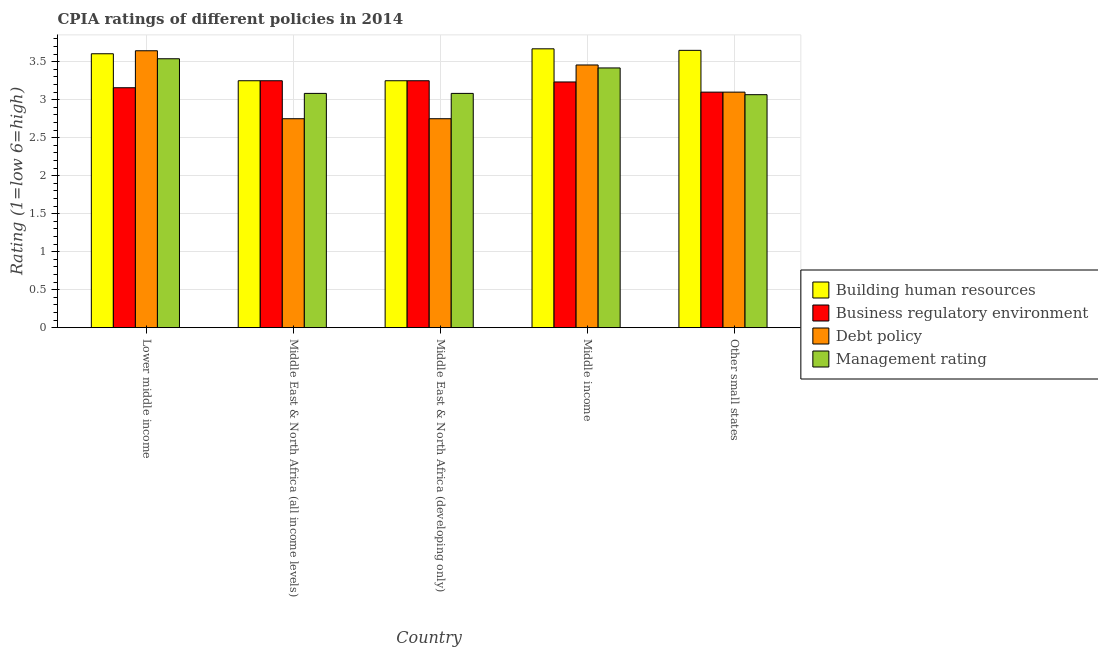How many different coloured bars are there?
Make the answer very short. 4. How many groups of bars are there?
Keep it short and to the point. 5. Are the number of bars per tick equal to the number of legend labels?
Your answer should be compact. Yes. Are the number of bars on each tick of the X-axis equal?
Your answer should be compact. Yes. How many bars are there on the 5th tick from the right?
Offer a very short reply. 4. What is the label of the 3rd group of bars from the left?
Ensure brevity in your answer.  Middle East & North Africa (developing only). In how many cases, is the number of bars for a given country not equal to the number of legend labels?
Give a very brief answer. 0. What is the cpia rating of building human resources in Lower middle income?
Your response must be concise. 3.61. Across all countries, what is the maximum cpia rating of building human resources?
Keep it short and to the point. 3.67. Across all countries, what is the minimum cpia rating of building human resources?
Your answer should be very brief. 3.25. In which country was the cpia rating of debt policy maximum?
Provide a succinct answer. Lower middle income. In which country was the cpia rating of management minimum?
Make the answer very short. Other small states. What is the total cpia rating of building human resources in the graph?
Make the answer very short. 17.43. What is the difference between the cpia rating of building human resources in Middle income and that in Other small states?
Your answer should be compact. 0.02. What is the difference between the cpia rating of building human resources in Middle East & North Africa (developing only) and the cpia rating of management in Middle East & North Africa (all income levels)?
Provide a succinct answer. 0.17. What is the average cpia rating of management per country?
Offer a terse response. 3.24. What is the difference between the cpia rating of debt policy and cpia rating of business regulatory environment in Middle income?
Your answer should be compact. 0.22. What is the ratio of the cpia rating of building human resources in Lower middle income to that in Other small states?
Provide a short and direct response. 0.99. Is the difference between the cpia rating of building human resources in Middle East & North Africa (all income levels) and Middle income greater than the difference between the cpia rating of debt policy in Middle East & North Africa (all income levels) and Middle income?
Keep it short and to the point. Yes. What is the difference between the highest and the second highest cpia rating of business regulatory environment?
Ensure brevity in your answer.  0. What is the difference between the highest and the lowest cpia rating of building human resources?
Keep it short and to the point. 0.42. In how many countries, is the cpia rating of building human resources greater than the average cpia rating of building human resources taken over all countries?
Offer a terse response. 3. What does the 1st bar from the left in Middle East & North Africa (developing only) represents?
Provide a succinct answer. Building human resources. What does the 2nd bar from the right in Other small states represents?
Your response must be concise. Debt policy. Is it the case that in every country, the sum of the cpia rating of building human resources and cpia rating of business regulatory environment is greater than the cpia rating of debt policy?
Make the answer very short. Yes. How many bars are there?
Offer a very short reply. 20. Are all the bars in the graph horizontal?
Make the answer very short. No. How many countries are there in the graph?
Your answer should be compact. 5. What is the difference between two consecutive major ticks on the Y-axis?
Your response must be concise. 0.5. Are the values on the major ticks of Y-axis written in scientific E-notation?
Your response must be concise. No. Does the graph contain any zero values?
Provide a succinct answer. No. Does the graph contain grids?
Give a very brief answer. Yes. How are the legend labels stacked?
Keep it short and to the point. Vertical. What is the title of the graph?
Give a very brief answer. CPIA ratings of different policies in 2014. What is the label or title of the X-axis?
Provide a succinct answer. Country. What is the Rating (1=low 6=high) in Building human resources in Lower middle income?
Your answer should be compact. 3.61. What is the Rating (1=low 6=high) in Business regulatory environment in Lower middle income?
Keep it short and to the point. 3.16. What is the Rating (1=low 6=high) in Debt policy in Lower middle income?
Your answer should be compact. 3.64. What is the Rating (1=low 6=high) of Management rating in Lower middle income?
Make the answer very short. 3.54. What is the Rating (1=low 6=high) in Building human resources in Middle East & North Africa (all income levels)?
Your response must be concise. 3.25. What is the Rating (1=low 6=high) in Debt policy in Middle East & North Africa (all income levels)?
Offer a very short reply. 2.75. What is the Rating (1=low 6=high) of Management rating in Middle East & North Africa (all income levels)?
Keep it short and to the point. 3.08. What is the Rating (1=low 6=high) of Building human resources in Middle East & North Africa (developing only)?
Your response must be concise. 3.25. What is the Rating (1=low 6=high) in Debt policy in Middle East & North Africa (developing only)?
Make the answer very short. 2.75. What is the Rating (1=low 6=high) in Management rating in Middle East & North Africa (developing only)?
Offer a very short reply. 3.08. What is the Rating (1=low 6=high) of Building human resources in Middle income?
Provide a short and direct response. 3.67. What is the Rating (1=low 6=high) in Business regulatory environment in Middle income?
Your response must be concise. 3.23. What is the Rating (1=low 6=high) in Debt policy in Middle income?
Offer a terse response. 3.46. What is the Rating (1=low 6=high) of Management rating in Middle income?
Give a very brief answer. 3.42. What is the Rating (1=low 6=high) of Building human resources in Other small states?
Your response must be concise. 3.65. What is the Rating (1=low 6=high) of Debt policy in Other small states?
Ensure brevity in your answer.  3.1. What is the Rating (1=low 6=high) of Management rating in Other small states?
Provide a short and direct response. 3.07. Across all countries, what is the maximum Rating (1=low 6=high) of Building human resources?
Your response must be concise. 3.67. Across all countries, what is the maximum Rating (1=low 6=high) in Business regulatory environment?
Your answer should be very brief. 3.25. Across all countries, what is the maximum Rating (1=low 6=high) of Debt policy?
Offer a very short reply. 3.64. Across all countries, what is the maximum Rating (1=low 6=high) in Management rating?
Provide a short and direct response. 3.54. Across all countries, what is the minimum Rating (1=low 6=high) of Business regulatory environment?
Your answer should be compact. 3.1. Across all countries, what is the minimum Rating (1=low 6=high) of Debt policy?
Give a very brief answer. 2.75. Across all countries, what is the minimum Rating (1=low 6=high) of Management rating?
Provide a short and direct response. 3.07. What is the total Rating (1=low 6=high) in Building human resources in the graph?
Give a very brief answer. 17.43. What is the total Rating (1=low 6=high) in Business regulatory environment in the graph?
Your answer should be compact. 15.99. What is the total Rating (1=low 6=high) in Debt policy in the graph?
Your answer should be very brief. 15.7. What is the total Rating (1=low 6=high) of Management rating in the graph?
Provide a succinct answer. 16.19. What is the difference between the Rating (1=low 6=high) of Building human resources in Lower middle income and that in Middle East & North Africa (all income levels)?
Make the answer very short. 0.36. What is the difference between the Rating (1=low 6=high) in Business regulatory environment in Lower middle income and that in Middle East & North Africa (all income levels)?
Give a very brief answer. -0.09. What is the difference between the Rating (1=low 6=high) of Debt policy in Lower middle income and that in Middle East & North Africa (all income levels)?
Offer a terse response. 0.89. What is the difference between the Rating (1=low 6=high) in Management rating in Lower middle income and that in Middle East & North Africa (all income levels)?
Make the answer very short. 0.46. What is the difference between the Rating (1=low 6=high) of Building human resources in Lower middle income and that in Middle East & North Africa (developing only)?
Ensure brevity in your answer.  0.36. What is the difference between the Rating (1=low 6=high) in Business regulatory environment in Lower middle income and that in Middle East & North Africa (developing only)?
Provide a succinct answer. -0.09. What is the difference between the Rating (1=low 6=high) in Debt policy in Lower middle income and that in Middle East & North Africa (developing only)?
Make the answer very short. 0.89. What is the difference between the Rating (1=low 6=high) of Management rating in Lower middle income and that in Middle East & North Africa (developing only)?
Make the answer very short. 0.46. What is the difference between the Rating (1=low 6=high) of Building human resources in Lower middle income and that in Middle income?
Your answer should be very brief. -0.06. What is the difference between the Rating (1=low 6=high) in Business regulatory environment in Lower middle income and that in Middle income?
Offer a terse response. -0.08. What is the difference between the Rating (1=low 6=high) of Debt policy in Lower middle income and that in Middle income?
Make the answer very short. 0.19. What is the difference between the Rating (1=low 6=high) of Management rating in Lower middle income and that in Middle income?
Your answer should be compact. 0.12. What is the difference between the Rating (1=low 6=high) of Building human resources in Lower middle income and that in Other small states?
Your answer should be compact. -0.04. What is the difference between the Rating (1=low 6=high) in Business regulatory environment in Lower middle income and that in Other small states?
Ensure brevity in your answer.  0.06. What is the difference between the Rating (1=low 6=high) of Debt policy in Lower middle income and that in Other small states?
Make the answer very short. 0.54. What is the difference between the Rating (1=low 6=high) in Management rating in Lower middle income and that in Other small states?
Provide a succinct answer. 0.47. What is the difference between the Rating (1=low 6=high) of Business regulatory environment in Middle East & North Africa (all income levels) and that in Middle East & North Africa (developing only)?
Provide a short and direct response. 0. What is the difference between the Rating (1=low 6=high) of Debt policy in Middle East & North Africa (all income levels) and that in Middle East & North Africa (developing only)?
Offer a terse response. 0. What is the difference between the Rating (1=low 6=high) in Management rating in Middle East & North Africa (all income levels) and that in Middle East & North Africa (developing only)?
Offer a terse response. 0. What is the difference between the Rating (1=low 6=high) of Building human resources in Middle East & North Africa (all income levels) and that in Middle income?
Provide a short and direct response. -0.42. What is the difference between the Rating (1=low 6=high) in Business regulatory environment in Middle East & North Africa (all income levels) and that in Middle income?
Provide a succinct answer. 0.02. What is the difference between the Rating (1=low 6=high) of Debt policy in Middle East & North Africa (all income levels) and that in Middle income?
Offer a terse response. -0.71. What is the difference between the Rating (1=low 6=high) of Management rating in Middle East & North Africa (all income levels) and that in Middle income?
Provide a short and direct response. -0.34. What is the difference between the Rating (1=low 6=high) of Building human resources in Middle East & North Africa (all income levels) and that in Other small states?
Provide a succinct answer. -0.4. What is the difference between the Rating (1=low 6=high) of Debt policy in Middle East & North Africa (all income levels) and that in Other small states?
Provide a short and direct response. -0.35. What is the difference between the Rating (1=low 6=high) of Management rating in Middle East & North Africa (all income levels) and that in Other small states?
Your answer should be very brief. 0.02. What is the difference between the Rating (1=low 6=high) in Building human resources in Middle East & North Africa (developing only) and that in Middle income?
Keep it short and to the point. -0.42. What is the difference between the Rating (1=low 6=high) in Business regulatory environment in Middle East & North Africa (developing only) and that in Middle income?
Provide a succinct answer. 0.02. What is the difference between the Rating (1=low 6=high) in Debt policy in Middle East & North Africa (developing only) and that in Middle income?
Make the answer very short. -0.71. What is the difference between the Rating (1=low 6=high) in Management rating in Middle East & North Africa (developing only) and that in Middle income?
Your answer should be very brief. -0.34. What is the difference between the Rating (1=low 6=high) of Building human resources in Middle East & North Africa (developing only) and that in Other small states?
Offer a very short reply. -0.4. What is the difference between the Rating (1=low 6=high) in Debt policy in Middle East & North Africa (developing only) and that in Other small states?
Your response must be concise. -0.35. What is the difference between the Rating (1=low 6=high) in Management rating in Middle East & North Africa (developing only) and that in Other small states?
Your response must be concise. 0.02. What is the difference between the Rating (1=low 6=high) of Building human resources in Middle income and that in Other small states?
Provide a short and direct response. 0.02. What is the difference between the Rating (1=low 6=high) of Business regulatory environment in Middle income and that in Other small states?
Ensure brevity in your answer.  0.13. What is the difference between the Rating (1=low 6=high) in Debt policy in Middle income and that in Other small states?
Give a very brief answer. 0.36. What is the difference between the Rating (1=low 6=high) in Management rating in Middle income and that in Other small states?
Keep it short and to the point. 0.35. What is the difference between the Rating (1=low 6=high) of Building human resources in Lower middle income and the Rating (1=low 6=high) of Business regulatory environment in Middle East & North Africa (all income levels)?
Keep it short and to the point. 0.36. What is the difference between the Rating (1=low 6=high) of Building human resources in Lower middle income and the Rating (1=low 6=high) of Debt policy in Middle East & North Africa (all income levels)?
Your response must be concise. 0.86. What is the difference between the Rating (1=low 6=high) in Building human resources in Lower middle income and the Rating (1=low 6=high) in Management rating in Middle East & North Africa (all income levels)?
Your answer should be very brief. 0.52. What is the difference between the Rating (1=low 6=high) of Business regulatory environment in Lower middle income and the Rating (1=low 6=high) of Debt policy in Middle East & North Africa (all income levels)?
Offer a very short reply. 0.41. What is the difference between the Rating (1=low 6=high) of Business regulatory environment in Lower middle income and the Rating (1=low 6=high) of Management rating in Middle East & North Africa (all income levels)?
Make the answer very short. 0.07. What is the difference between the Rating (1=low 6=high) in Debt policy in Lower middle income and the Rating (1=low 6=high) in Management rating in Middle East & North Africa (all income levels)?
Your response must be concise. 0.56. What is the difference between the Rating (1=low 6=high) in Building human resources in Lower middle income and the Rating (1=low 6=high) in Business regulatory environment in Middle East & North Africa (developing only)?
Ensure brevity in your answer.  0.36. What is the difference between the Rating (1=low 6=high) in Building human resources in Lower middle income and the Rating (1=low 6=high) in Debt policy in Middle East & North Africa (developing only)?
Offer a very short reply. 0.86. What is the difference between the Rating (1=low 6=high) in Building human resources in Lower middle income and the Rating (1=low 6=high) in Management rating in Middle East & North Africa (developing only)?
Your answer should be compact. 0.52. What is the difference between the Rating (1=low 6=high) in Business regulatory environment in Lower middle income and the Rating (1=low 6=high) in Debt policy in Middle East & North Africa (developing only)?
Provide a short and direct response. 0.41. What is the difference between the Rating (1=low 6=high) in Business regulatory environment in Lower middle income and the Rating (1=low 6=high) in Management rating in Middle East & North Africa (developing only)?
Offer a very short reply. 0.07. What is the difference between the Rating (1=low 6=high) of Debt policy in Lower middle income and the Rating (1=low 6=high) of Management rating in Middle East & North Africa (developing only)?
Your answer should be compact. 0.56. What is the difference between the Rating (1=low 6=high) of Building human resources in Lower middle income and the Rating (1=low 6=high) of Business regulatory environment in Middle income?
Provide a succinct answer. 0.37. What is the difference between the Rating (1=low 6=high) of Building human resources in Lower middle income and the Rating (1=low 6=high) of Debt policy in Middle income?
Keep it short and to the point. 0.15. What is the difference between the Rating (1=low 6=high) of Building human resources in Lower middle income and the Rating (1=low 6=high) of Management rating in Middle income?
Keep it short and to the point. 0.19. What is the difference between the Rating (1=low 6=high) of Business regulatory environment in Lower middle income and the Rating (1=low 6=high) of Debt policy in Middle income?
Your answer should be very brief. -0.3. What is the difference between the Rating (1=low 6=high) of Business regulatory environment in Lower middle income and the Rating (1=low 6=high) of Management rating in Middle income?
Keep it short and to the point. -0.26. What is the difference between the Rating (1=low 6=high) of Debt policy in Lower middle income and the Rating (1=low 6=high) of Management rating in Middle income?
Your answer should be compact. 0.23. What is the difference between the Rating (1=low 6=high) in Building human resources in Lower middle income and the Rating (1=low 6=high) in Business regulatory environment in Other small states?
Offer a terse response. 0.51. What is the difference between the Rating (1=low 6=high) of Building human resources in Lower middle income and the Rating (1=low 6=high) of Debt policy in Other small states?
Your answer should be very brief. 0.51. What is the difference between the Rating (1=low 6=high) of Building human resources in Lower middle income and the Rating (1=low 6=high) of Management rating in Other small states?
Offer a terse response. 0.54. What is the difference between the Rating (1=low 6=high) of Business regulatory environment in Lower middle income and the Rating (1=low 6=high) of Debt policy in Other small states?
Your answer should be compact. 0.06. What is the difference between the Rating (1=low 6=high) of Business regulatory environment in Lower middle income and the Rating (1=low 6=high) of Management rating in Other small states?
Keep it short and to the point. 0.09. What is the difference between the Rating (1=low 6=high) of Debt policy in Lower middle income and the Rating (1=low 6=high) of Management rating in Other small states?
Make the answer very short. 0.58. What is the difference between the Rating (1=low 6=high) in Building human resources in Middle East & North Africa (all income levels) and the Rating (1=low 6=high) in Business regulatory environment in Middle East & North Africa (developing only)?
Keep it short and to the point. 0. What is the difference between the Rating (1=low 6=high) in Building human resources in Middle East & North Africa (all income levels) and the Rating (1=low 6=high) in Management rating in Middle East & North Africa (developing only)?
Your answer should be very brief. 0.17. What is the difference between the Rating (1=low 6=high) in Business regulatory environment in Middle East & North Africa (all income levels) and the Rating (1=low 6=high) in Debt policy in Middle East & North Africa (developing only)?
Offer a terse response. 0.5. What is the difference between the Rating (1=low 6=high) in Business regulatory environment in Middle East & North Africa (all income levels) and the Rating (1=low 6=high) in Management rating in Middle East & North Africa (developing only)?
Make the answer very short. 0.17. What is the difference between the Rating (1=low 6=high) of Debt policy in Middle East & North Africa (all income levels) and the Rating (1=low 6=high) of Management rating in Middle East & North Africa (developing only)?
Your answer should be very brief. -0.33. What is the difference between the Rating (1=low 6=high) in Building human resources in Middle East & North Africa (all income levels) and the Rating (1=low 6=high) in Business regulatory environment in Middle income?
Your answer should be very brief. 0.02. What is the difference between the Rating (1=low 6=high) of Building human resources in Middle East & North Africa (all income levels) and the Rating (1=low 6=high) of Debt policy in Middle income?
Your response must be concise. -0.21. What is the difference between the Rating (1=low 6=high) of Building human resources in Middle East & North Africa (all income levels) and the Rating (1=low 6=high) of Management rating in Middle income?
Your answer should be compact. -0.17. What is the difference between the Rating (1=low 6=high) of Business regulatory environment in Middle East & North Africa (all income levels) and the Rating (1=low 6=high) of Debt policy in Middle income?
Make the answer very short. -0.21. What is the difference between the Rating (1=low 6=high) of Business regulatory environment in Middle East & North Africa (all income levels) and the Rating (1=low 6=high) of Management rating in Middle income?
Your answer should be very brief. -0.17. What is the difference between the Rating (1=low 6=high) in Debt policy in Middle East & North Africa (all income levels) and the Rating (1=low 6=high) in Management rating in Middle income?
Make the answer very short. -0.67. What is the difference between the Rating (1=low 6=high) in Building human resources in Middle East & North Africa (all income levels) and the Rating (1=low 6=high) in Business regulatory environment in Other small states?
Ensure brevity in your answer.  0.15. What is the difference between the Rating (1=low 6=high) in Building human resources in Middle East & North Africa (all income levels) and the Rating (1=low 6=high) in Debt policy in Other small states?
Ensure brevity in your answer.  0.15. What is the difference between the Rating (1=low 6=high) in Building human resources in Middle East & North Africa (all income levels) and the Rating (1=low 6=high) in Management rating in Other small states?
Give a very brief answer. 0.18. What is the difference between the Rating (1=low 6=high) of Business regulatory environment in Middle East & North Africa (all income levels) and the Rating (1=low 6=high) of Management rating in Other small states?
Ensure brevity in your answer.  0.18. What is the difference between the Rating (1=low 6=high) of Debt policy in Middle East & North Africa (all income levels) and the Rating (1=low 6=high) of Management rating in Other small states?
Make the answer very short. -0.32. What is the difference between the Rating (1=low 6=high) in Building human resources in Middle East & North Africa (developing only) and the Rating (1=low 6=high) in Business regulatory environment in Middle income?
Your response must be concise. 0.02. What is the difference between the Rating (1=low 6=high) of Building human resources in Middle East & North Africa (developing only) and the Rating (1=low 6=high) of Debt policy in Middle income?
Ensure brevity in your answer.  -0.21. What is the difference between the Rating (1=low 6=high) of Building human resources in Middle East & North Africa (developing only) and the Rating (1=low 6=high) of Management rating in Middle income?
Provide a succinct answer. -0.17. What is the difference between the Rating (1=low 6=high) in Business regulatory environment in Middle East & North Africa (developing only) and the Rating (1=low 6=high) in Debt policy in Middle income?
Your answer should be compact. -0.21. What is the difference between the Rating (1=low 6=high) in Business regulatory environment in Middle East & North Africa (developing only) and the Rating (1=low 6=high) in Management rating in Middle income?
Offer a very short reply. -0.17. What is the difference between the Rating (1=low 6=high) of Debt policy in Middle East & North Africa (developing only) and the Rating (1=low 6=high) of Management rating in Middle income?
Provide a short and direct response. -0.67. What is the difference between the Rating (1=low 6=high) in Building human resources in Middle East & North Africa (developing only) and the Rating (1=low 6=high) in Business regulatory environment in Other small states?
Ensure brevity in your answer.  0.15. What is the difference between the Rating (1=low 6=high) in Building human resources in Middle East & North Africa (developing only) and the Rating (1=low 6=high) in Management rating in Other small states?
Keep it short and to the point. 0.18. What is the difference between the Rating (1=low 6=high) in Business regulatory environment in Middle East & North Africa (developing only) and the Rating (1=low 6=high) in Debt policy in Other small states?
Make the answer very short. 0.15. What is the difference between the Rating (1=low 6=high) of Business regulatory environment in Middle East & North Africa (developing only) and the Rating (1=low 6=high) of Management rating in Other small states?
Your answer should be very brief. 0.18. What is the difference between the Rating (1=low 6=high) of Debt policy in Middle East & North Africa (developing only) and the Rating (1=low 6=high) of Management rating in Other small states?
Your answer should be very brief. -0.32. What is the difference between the Rating (1=low 6=high) in Building human resources in Middle income and the Rating (1=low 6=high) in Business regulatory environment in Other small states?
Your answer should be compact. 0.57. What is the difference between the Rating (1=low 6=high) in Building human resources in Middle income and the Rating (1=low 6=high) in Debt policy in Other small states?
Provide a short and direct response. 0.57. What is the difference between the Rating (1=low 6=high) in Building human resources in Middle income and the Rating (1=low 6=high) in Management rating in Other small states?
Your answer should be very brief. 0.6. What is the difference between the Rating (1=low 6=high) in Business regulatory environment in Middle income and the Rating (1=low 6=high) in Debt policy in Other small states?
Give a very brief answer. 0.13. What is the difference between the Rating (1=low 6=high) in Business regulatory environment in Middle income and the Rating (1=low 6=high) in Management rating in Other small states?
Offer a very short reply. 0.17. What is the difference between the Rating (1=low 6=high) of Debt policy in Middle income and the Rating (1=low 6=high) of Management rating in Other small states?
Provide a succinct answer. 0.39. What is the average Rating (1=low 6=high) of Building human resources per country?
Your answer should be very brief. 3.49. What is the average Rating (1=low 6=high) of Business regulatory environment per country?
Make the answer very short. 3.2. What is the average Rating (1=low 6=high) in Debt policy per country?
Keep it short and to the point. 3.14. What is the average Rating (1=low 6=high) in Management rating per country?
Your response must be concise. 3.24. What is the difference between the Rating (1=low 6=high) of Building human resources and Rating (1=low 6=high) of Business regulatory environment in Lower middle income?
Give a very brief answer. 0.45. What is the difference between the Rating (1=low 6=high) of Building human resources and Rating (1=low 6=high) of Debt policy in Lower middle income?
Offer a terse response. -0.04. What is the difference between the Rating (1=low 6=high) of Building human resources and Rating (1=low 6=high) of Management rating in Lower middle income?
Keep it short and to the point. 0.07. What is the difference between the Rating (1=low 6=high) of Business regulatory environment and Rating (1=low 6=high) of Debt policy in Lower middle income?
Offer a very short reply. -0.49. What is the difference between the Rating (1=low 6=high) in Business regulatory environment and Rating (1=low 6=high) in Management rating in Lower middle income?
Provide a short and direct response. -0.38. What is the difference between the Rating (1=low 6=high) in Debt policy and Rating (1=low 6=high) in Management rating in Lower middle income?
Provide a succinct answer. 0.11. What is the difference between the Rating (1=low 6=high) in Building human resources and Rating (1=low 6=high) in Management rating in Middle East & North Africa (all income levels)?
Ensure brevity in your answer.  0.17. What is the difference between the Rating (1=low 6=high) in Business regulatory environment and Rating (1=low 6=high) in Debt policy in Middle East & North Africa (all income levels)?
Offer a terse response. 0.5. What is the difference between the Rating (1=low 6=high) in Building human resources and Rating (1=low 6=high) in Business regulatory environment in Middle East & North Africa (developing only)?
Your answer should be very brief. 0. What is the difference between the Rating (1=low 6=high) of Building human resources and Rating (1=low 6=high) of Management rating in Middle East & North Africa (developing only)?
Provide a succinct answer. 0.17. What is the difference between the Rating (1=low 6=high) in Business regulatory environment and Rating (1=low 6=high) in Management rating in Middle East & North Africa (developing only)?
Provide a short and direct response. 0.17. What is the difference between the Rating (1=low 6=high) of Debt policy and Rating (1=low 6=high) of Management rating in Middle East & North Africa (developing only)?
Offer a terse response. -0.33. What is the difference between the Rating (1=low 6=high) in Building human resources and Rating (1=low 6=high) in Business regulatory environment in Middle income?
Your answer should be very brief. 0.44. What is the difference between the Rating (1=low 6=high) in Building human resources and Rating (1=low 6=high) in Debt policy in Middle income?
Keep it short and to the point. 0.21. What is the difference between the Rating (1=low 6=high) in Building human resources and Rating (1=low 6=high) in Management rating in Middle income?
Give a very brief answer. 0.25. What is the difference between the Rating (1=low 6=high) in Business regulatory environment and Rating (1=low 6=high) in Debt policy in Middle income?
Provide a short and direct response. -0.22. What is the difference between the Rating (1=low 6=high) of Business regulatory environment and Rating (1=low 6=high) of Management rating in Middle income?
Provide a succinct answer. -0.18. What is the difference between the Rating (1=low 6=high) in Debt policy and Rating (1=low 6=high) in Management rating in Middle income?
Keep it short and to the point. 0.04. What is the difference between the Rating (1=low 6=high) of Building human resources and Rating (1=low 6=high) of Business regulatory environment in Other small states?
Give a very brief answer. 0.55. What is the difference between the Rating (1=low 6=high) of Building human resources and Rating (1=low 6=high) of Debt policy in Other small states?
Keep it short and to the point. 0.55. What is the difference between the Rating (1=low 6=high) in Building human resources and Rating (1=low 6=high) in Management rating in Other small states?
Provide a short and direct response. 0.58. What is the difference between the Rating (1=low 6=high) in Business regulatory environment and Rating (1=low 6=high) in Debt policy in Other small states?
Keep it short and to the point. 0. What is the difference between the Rating (1=low 6=high) of Business regulatory environment and Rating (1=low 6=high) of Management rating in Other small states?
Your response must be concise. 0.03. What is the ratio of the Rating (1=low 6=high) of Building human resources in Lower middle income to that in Middle East & North Africa (all income levels)?
Provide a succinct answer. 1.11. What is the ratio of the Rating (1=low 6=high) of Business regulatory environment in Lower middle income to that in Middle East & North Africa (all income levels)?
Your response must be concise. 0.97. What is the ratio of the Rating (1=low 6=high) in Debt policy in Lower middle income to that in Middle East & North Africa (all income levels)?
Your response must be concise. 1.33. What is the ratio of the Rating (1=low 6=high) in Management rating in Lower middle income to that in Middle East & North Africa (all income levels)?
Keep it short and to the point. 1.15. What is the ratio of the Rating (1=low 6=high) of Building human resources in Lower middle income to that in Middle East & North Africa (developing only)?
Provide a short and direct response. 1.11. What is the ratio of the Rating (1=low 6=high) in Business regulatory environment in Lower middle income to that in Middle East & North Africa (developing only)?
Your response must be concise. 0.97. What is the ratio of the Rating (1=low 6=high) of Debt policy in Lower middle income to that in Middle East & North Africa (developing only)?
Make the answer very short. 1.33. What is the ratio of the Rating (1=low 6=high) in Management rating in Lower middle income to that in Middle East & North Africa (developing only)?
Your response must be concise. 1.15. What is the ratio of the Rating (1=low 6=high) in Building human resources in Lower middle income to that in Middle income?
Your response must be concise. 0.98. What is the ratio of the Rating (1=low 6=high) in Business regulatory environment in Lower middle income to that in Middle income?
Make the answer very short. 0.98. What is the ratio of the Rating (1=low 6=high) of Debt policy in Lower middle income to that in Middle income?
Provide a succinct answer. 1.05. What is the ratio of the Rating (1=low 6=high) in Management rating in Lower middle income to that in Middle income?
Ensure brevity in your answer.  1.04. What is the ratio of the Rating (1=low 6=high) of Building human resources in Lower middle income to that in Other small states?
Provide a short and direct response. 0.99. What is the ratio of the Rating (1=low 6=high) of Business regulatory environment in Lower middle income to that in Other small states?
Your answer should be very brief. 1.02. What is the ratio of the Rating (1=low 6=high) in Debt policy in Lower middle income to that in Other small states?
Keep it short and to the point. 1.18. What is the ratio of the Rating (1=low 6=high) of Management rating in Lower middle income to that in Other small states?
Your answer should be very brief. 1.15. What is the ratio of the Rating (1=low 6=high) in Management rating in Middle East & North Africa (all income levels) to that in Middle East & North Africa (developing only)?
Your answer should be compact. 1. What is the ratio of the Rating (1=low 6=high) of Building human resources in Middle East & North Africa (all income levels) to that in Middle income?
Provide a short and direct response. 0.89. What is the ratio of the Rating (1=low 6=high) in Debt policy in Middle East & North Africa (all income levels) to that in Middle income?
Provide a short and direct response. 0.8. What is the ratio of the Rating (1=low 6=high) of Management rating in Middle East & North Africa (all income levels) to that in Middle income?
Make the answer very short. 0.9. What is the ratio of the Rating (1=low 6=high) of Building human resources in Middle East & North Africa (all income levels) to that in Other small states?
Provide a succinct answer. 0.89. What is the ratio of the Rating (1=low 6=high) of Business regulatory environment in Middle East & North Africa (all income levels) to that in Other small states?
Make the answer very short. 1.05. What is the ratio of the Rating (1=low 6=high) of Debt policy in Middle East & North Africa (all income levels) to that in Other small states?
Your response must be concise. 0.89. What is the ratio of the Rating (1=low 6=high) of Management rating in Middle East & North Africa (all income levels) to that in Other small states?
Keep it short and to the point. 1.01. What is the ratio of the Rating (1=low 6=high) of Building human resources in Middle East & North Africa (developing only) to that in Middle income?
Give a very brief answer. 0.89. What is the ratio of the Rating (1=low 6=high) of Business regulatory environment in Middle East & North Africa (developing only) to that in Middle income?
Offer a very short reply. 1. What is the ratio of the Rating (1=low 6=high) in Debt policy in Middle East & North Africa (developing only) to that in Middle income?
Ensure brevity in your answer.  0.8. What is the ratio of the Rating (1=low 6=high) of Management rating in Middle East & North Africa (developing only) to that in Middle income?
Keep it short and to the point. 0.9. What is the ratio of the Rating (1=low 6=high) of Building human resources in Middle East & North Africa (developing only) to that in Other small states?
Give a very brief answer. 0.89. What is the ratio of the Rating (1=low 6=high) of Business regulatory environment in Middle East & North Africa (developing only) to that in Other small states?
Your response must be concise. 1.05. What is the ratio of the Rating (1=low 6=high) of Debt policy in Middle East & North Africa (developing only) to that in Other small states?
Keep it short and to the point. 0.89. What is the ratio of the Rating (1=low 6=high) of Management rating in Middle East & North Africa (developing only) to that in Other small states?
Offer a very short reply. 1.01. What is the ratio of the Rating (1=low 6=high) in Business regulatory environment in Middle income to that in Other small states?
Provide a short and direct response. 1.04. What is the ratio of the Rating (1=low 6=high) in Debt policy in Middle income to that in Other small states?
Provide a short and direct response. 1.12. What is the ratio of the Rating (1=low 6=high) in Management rating in Middle income to that in Other small states?
Keep it short and to the point. 1.11. What is the difference between the highest and the second highest Rating (1=low 6=high) of Building human resources?
Offer a terse response. 0.02. What is the difference between the highest and the second highest Rating (1=low 6=high) in Business regulatory environment?
Provide a short and direct response. 0. What is the difference between the highest and the second highest Rating (1=low 6=high) in Debt policy?
Your answer should be very brief. 0.19. What is the difference between the highest and the second highest Rating (1=low 6=high) of Management rating?
Ensure brevity in your answer.  0.12. What is the difference between the highest and the lowest Rating (1=low 6=high) of Building human resources?
Your response must be concise. 0.42. What is the difference between the highest and the lowest Rating (1=low 6=high) of Debt policy?
Provide a short and direct response. 0.89. What is the difference between the highest and the lowest Rating (1=low 6=high) of Management rating?
Make the answer very short. 0.47. 